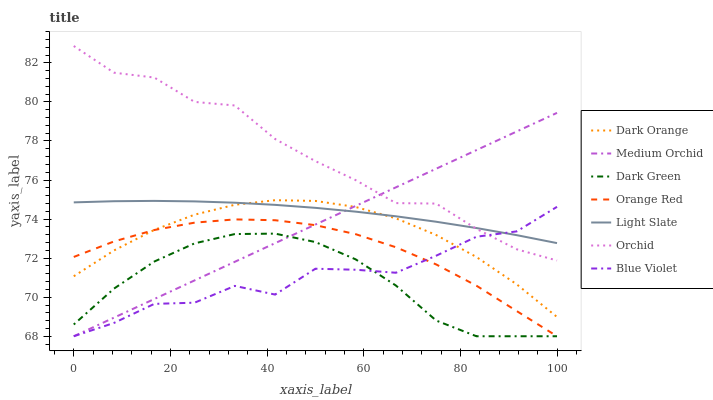Does Dark Green have the minimum area under the curve?
Answer yes or no. Yes. Does Orchid have the maximum area under the curve?
Answer yes or no. Yes. Does Light Slate have the minimum area under the curve?
Answer yes or no. No. Does Light Slate have the maximum area under the curve?
Answer yes or no. No. Is Medium Orchid the smoothest?
Answer yes or no. Yes. Is Blue Violet the roughest?
Answer yes or no. Yes. Is Light Slate the smoothest?
Answer yes or no. No. Is Light Slate the roughest?
Answer yes or no. No. Does Light Slate have the lowest value?
Answer yes or no. No. Does Orchid have the highest value?
Answer yes or no. Yes. Does Light Slate have the highest value?
Answer yes or no. No. Is Orange Red less than Orchid?
Answer yes or no. Yes. Is Light Slate greater than Orange Red?
Answer yes or no. Yes. Does Dark Orange intersect Light Slate?
Answer yes or no. Yes. Is Dark Orange less than Light Slate?
Answer yes or no. No. Is Dark Orange greater than Light Slate?
Answer yes or no. No. Does Orange Red intersect Orchid?
Answer yes or no. No. 